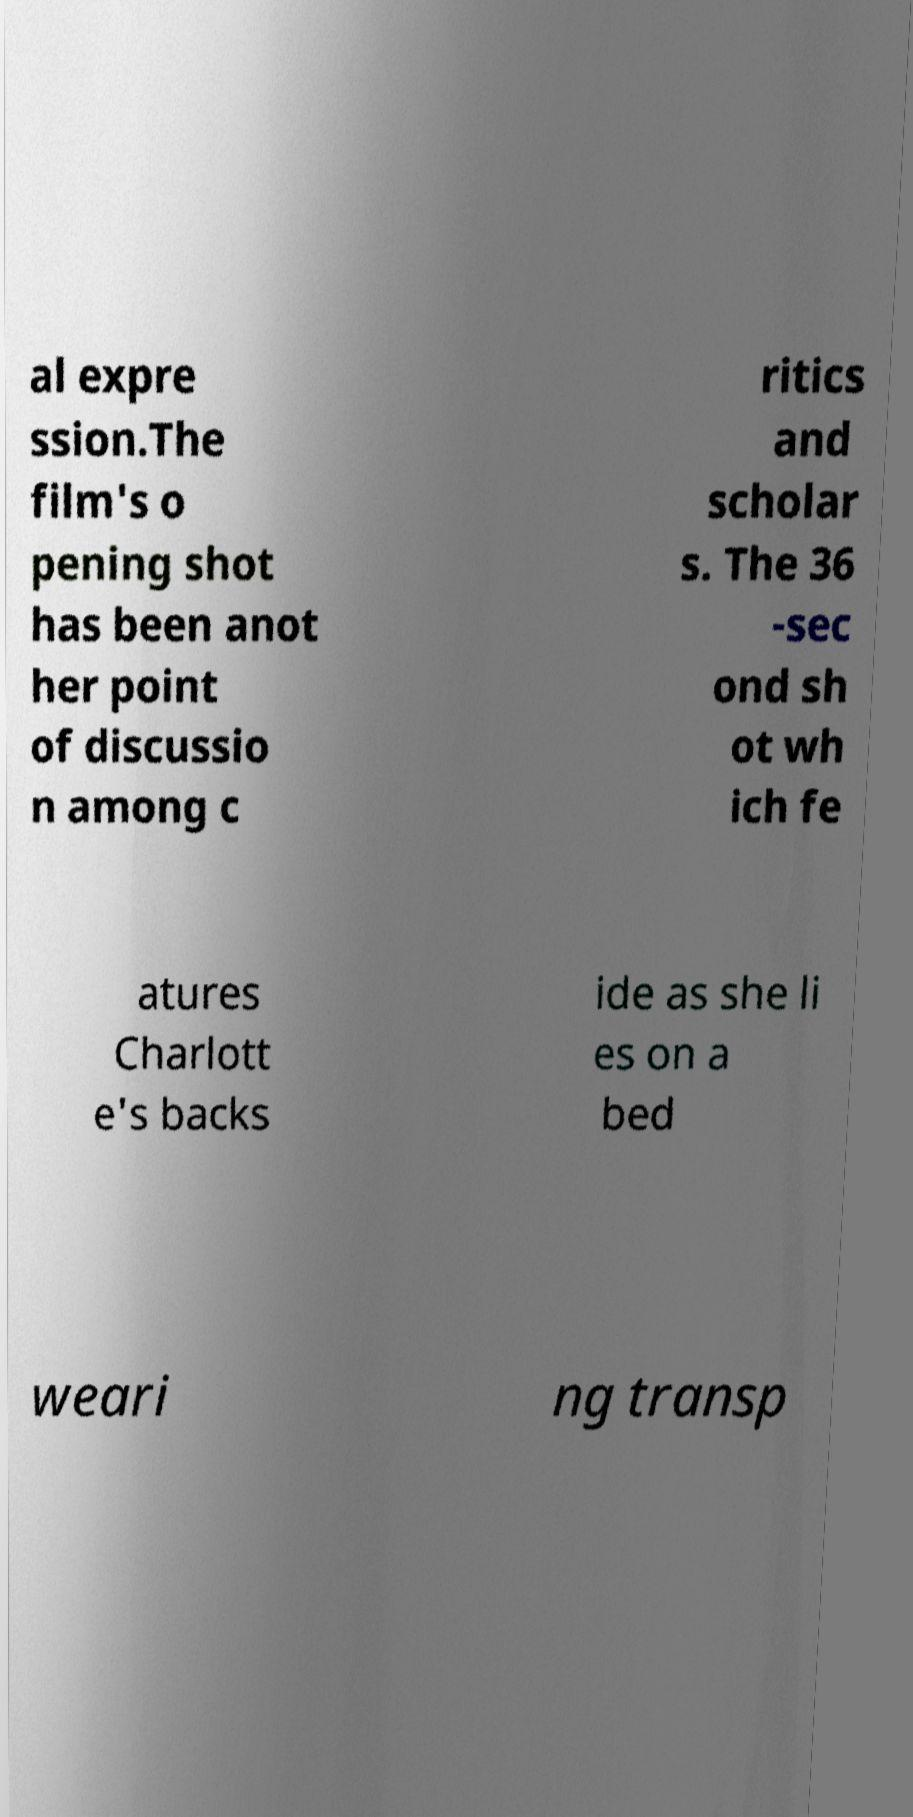Could you assist in decoding the text presented in this image and type it out clearly? al expre ssion.The film's o pening shot has been anot her point of discussio n among c ritics and scholar s. The 36 -sec ond sh ot wh ich fe atures Charlott e's backs ide as she li es on a bed weari ng transp 